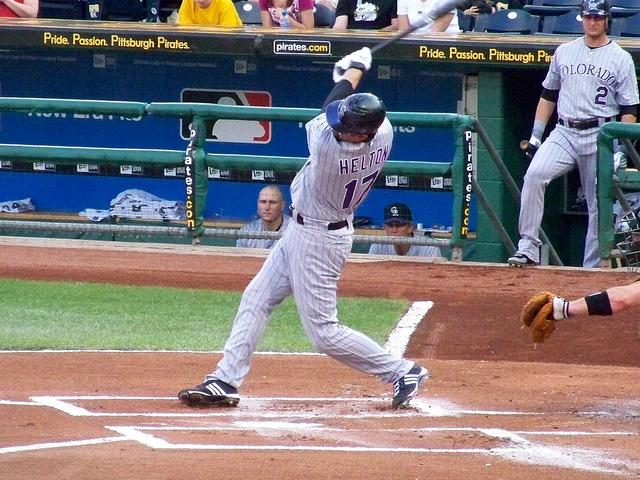Which city is the team in gray from? colorado 